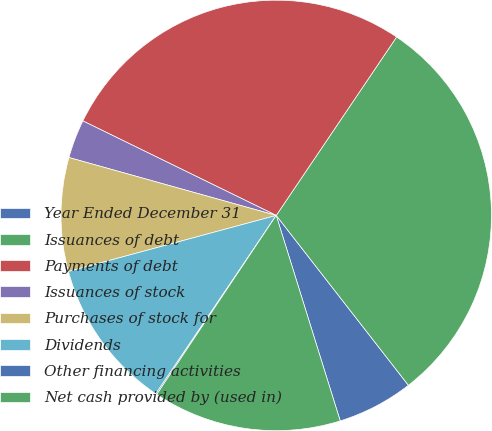<chart> <loc_0><loc_0><loc_500><loc_500><pie_chart><fcel>Year Ended December 31<fcel>Issuances of debt<fcel>Payments of debt<fcel>Issuances of stock<fcel>Purchases of stock for<fcel>Dividends<fcel>Other financing activities<fcel>Net cash provided by (used in)<nl><fcel>5.72%<fcel>30.03%<fcel>27.21%<fcel>2.9%<fcel>8.53%<fcel>11.35%<fcel>0.09%<fcel>14.17%<nl></chart> 